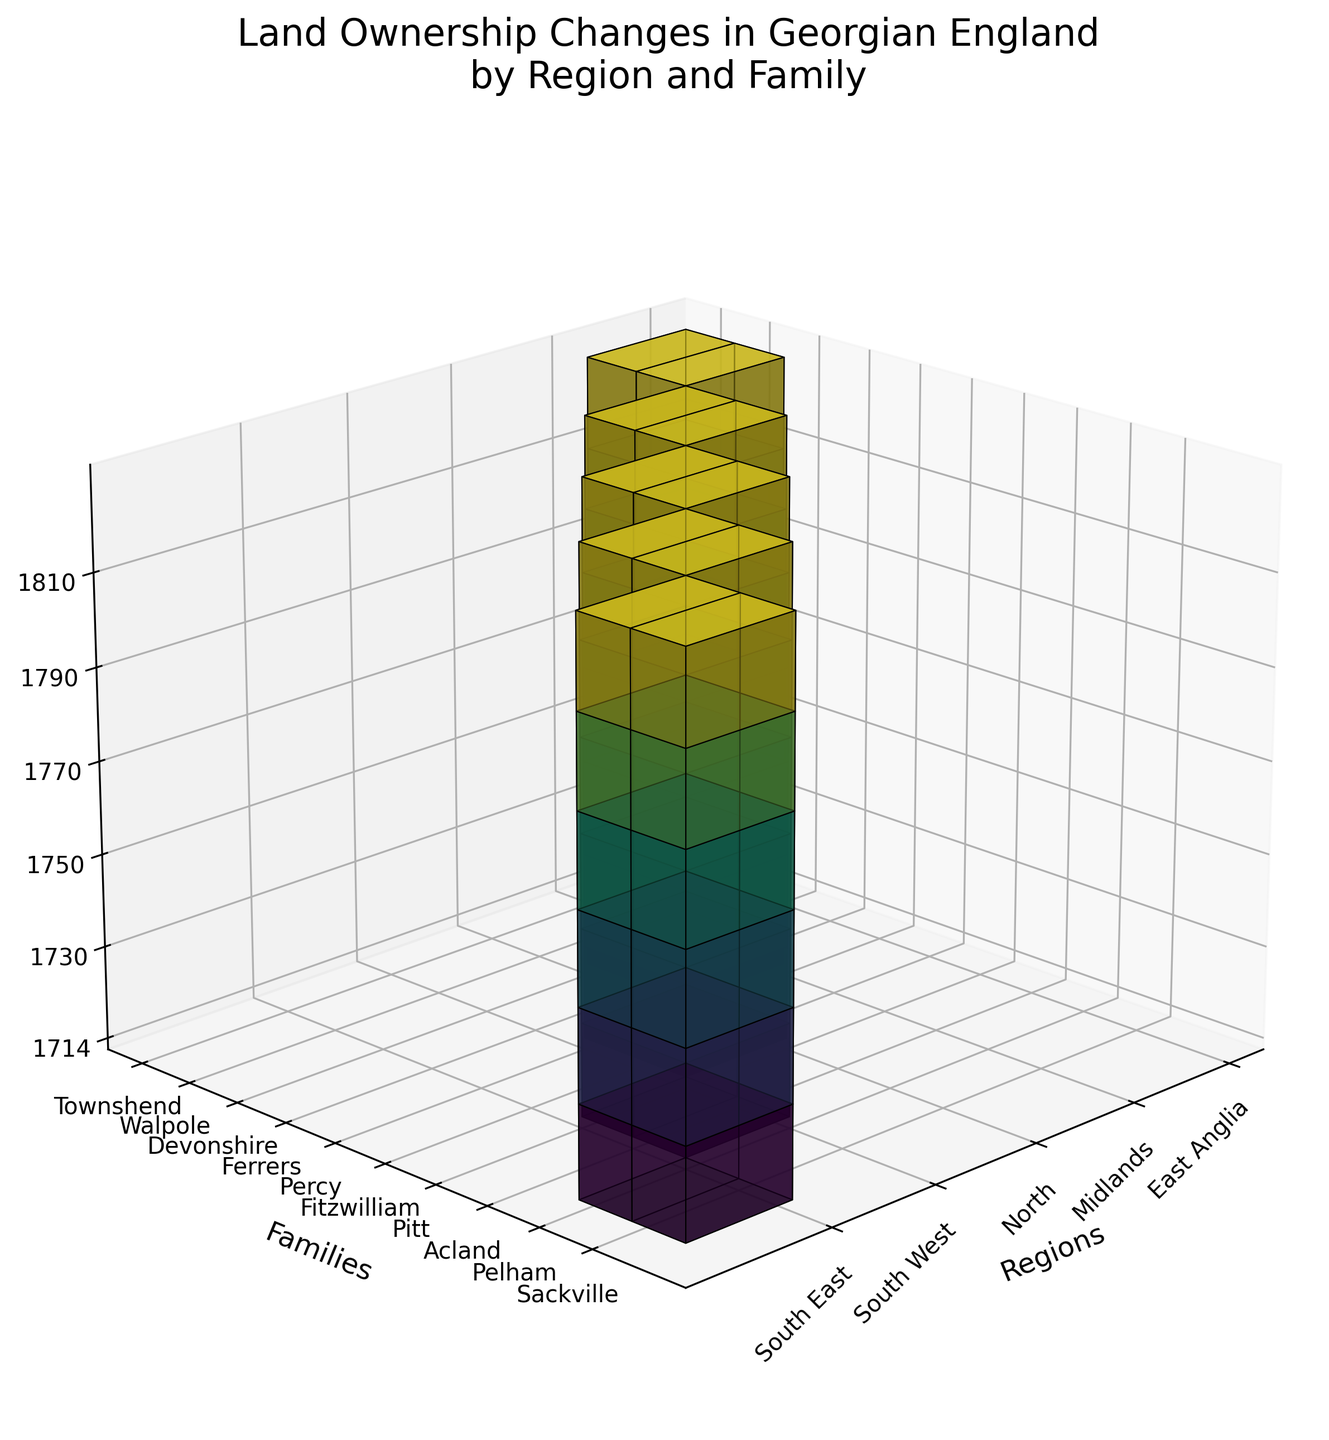Which family showed the most significant increase in land ownership in East Anglia by 1810? Compare the land ownership values in East Anglia for the Townshend and Walpole families from 1714 to 1810. Townshend starts at 12,000 and ends at 20,500 which is an increase of 8,500. Walpole starts at 8,000 and ends at 16,000 which is an increase of 8,000. Therefore, Townshend showed the most significant increase.
Answer: Townshend What is the title of the figure? The title of the figure is typically clearly written at the top of the plot. By reading it, the title is: "Land Ownership Changes in Georgian England by Region and Family".
Answer: Land Ownership Changes in Georgian England by Region and Family Which regions are represented in the figure? The regions are labeled on one of the axes. They include East Anglia, Midlands, North, South West, and South East.
Answer: East Anglia, Midlands, North, South West, South East During which year did the Percy family in the North region have the highest land ownership? To find the highest land ownership for the Percy family in the North region, look at the relevant section of the z-axis and find the year where the bar is tallest. In this case, it's 1810.
Answer: 1810 How many years are represented in the figure? By checking the z-axis labels, note that the figure includes the years 1714, 1730, 1750, 1770, 1790, and 1810, which means there are 6 years in total.
Answer: 6 Which family has the lowest land ownership in the Midlands throughout the entire period? Compare the heights of the bars for families in the Midlands region across all years. The Ferrers family shows consistently lower bars compared to the Devonshire family, indicating lower land ownership.
Answer: Ferrers Compare the total increase in land ownership for the Pelham family in the South East to the Fitzwilliam family in the North The Pelham family’s ownership increases from 18,000 in 1714 to 25,500 in 1810, a total increase of 7,500. The Fitzwilliam family’s ownership increases from 15,000 in 1714 to 22,500 in 1810, a total increase of 7,500. Both families have the same total increase.
Answer: 7,500 Which family in the South West had more land, on average, across the years shown? Calculate the average land ownership over the years for the Pitt and Acland families in the South West. Pitt: (10,000 + 11,000 + 12,000 + 13,000 + 14,000 + 15,000)/6 = 12,500. Acland: (7,000 + 7,500 + 8,000 + 8,500 + 9,000 + 9,500)/6 = 8,250. Thus, Pitt had more land on average.
Answer: Pitt What is the general trend in land ownership for the Devonshire family in the Midlands region? By looking at the sequence of bars for the Devonshire family in the Midlands region from 1714 to 1810, there is a clear upward trend, as each bar is taller than the last, indicating increasing land ownership.
Answer: Increasing Which family had continuous land ownership growth in the North region during the Georgian period? Examine the bars for each family in the North region. The Percy family’s bars continuously increase from 1714 to 1810 without any decrease.
Answer: Percy 